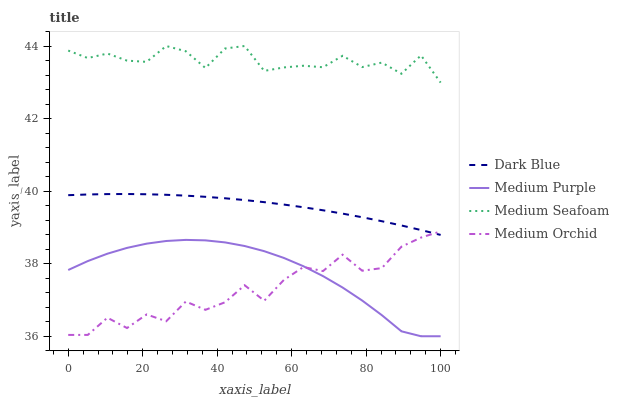Does Medium Orchid have the minimum area under the curve?
Answer yes or no. Yes. Does Medium Seafoam have the maximum area under the curve?
Answer yes or no. Yes. Does Dark Blue have the minimum area under the curve?
Answer yes or no. No. Does Dark Blue have the maximum area under the curve?
Answer yes or no. No. Is Dark Blue the smoothest?
Answer yes or no. Yes. Is Medium Orchid the roughest?
Answer yes or no. Yes. Is Medium Orchid the smoothest?
Answer yes or no. No. Is Dark Blue the roughest?
Answer yes or no. No. Does Medium Purple have the lowest value?
Answer yes or no. Yes. Does Dark Blue have the lowest value?
Answer yes or no. No. Does Medium Seafoam have the highest value?
Answer yes or no. Yes. Does Dark Blue have the highest value?
Answer yes or no. No. Is Medium Purple less than Medium Seafoam?
Answer yes or no. Yes. Is Medium Seafoam greater than Dark Blue?
Answer yes or no. Yes. Does Dark Blue intersect Medium Orchid?
Answer yes or no. Yes. Is Dark Blue less than Medium Orchid?
Answer yes or no. No. Is Dark Blue greater than Medium Orchid?
Answer yes or no. No. Does Medium Purple intersect Medium Seafoam?
Answer yes or no. No. 